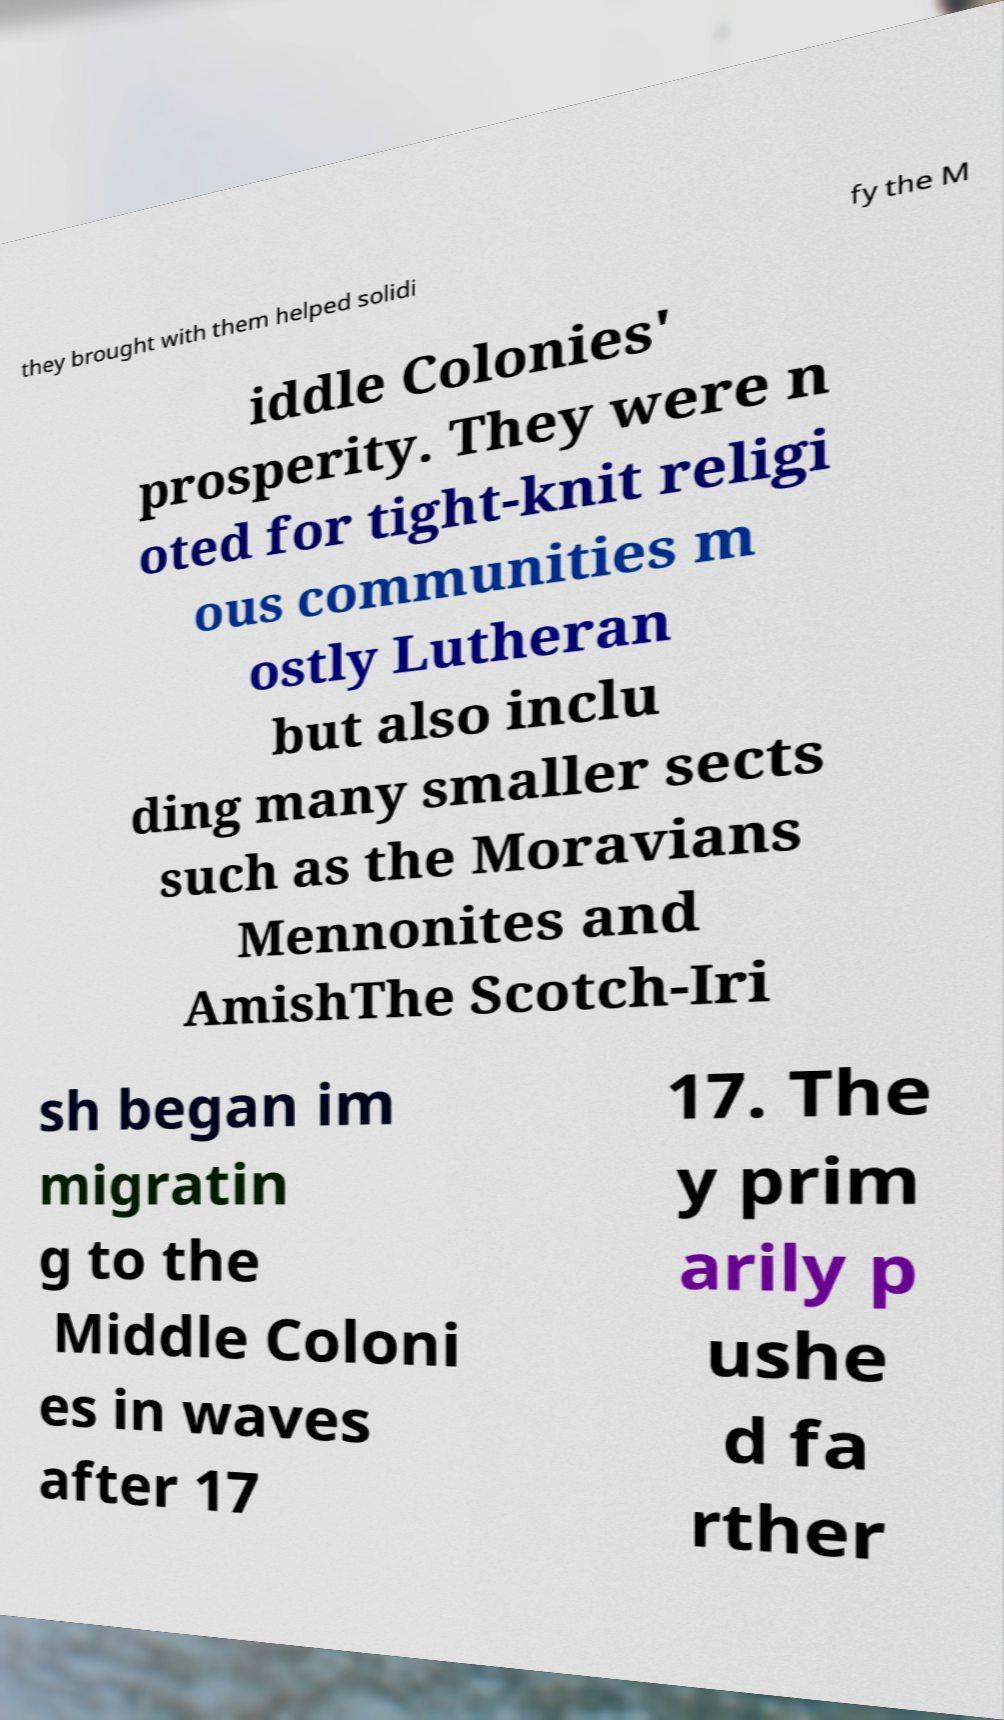Please read and relay the text visible in this image. What does it say? they brought with them helped solidi fy the M iddle Colonies' prosperity. They were n oted for tight-knit religi ous communities m ostly Lutheran but also inclu ding many smaller sects such as the Moravians Mennonites and AmishThe Scotch-Iri sh began im migratin g to the Middle Coloni es in waves after 17 17. The y prim arily p ushe d fa rther 